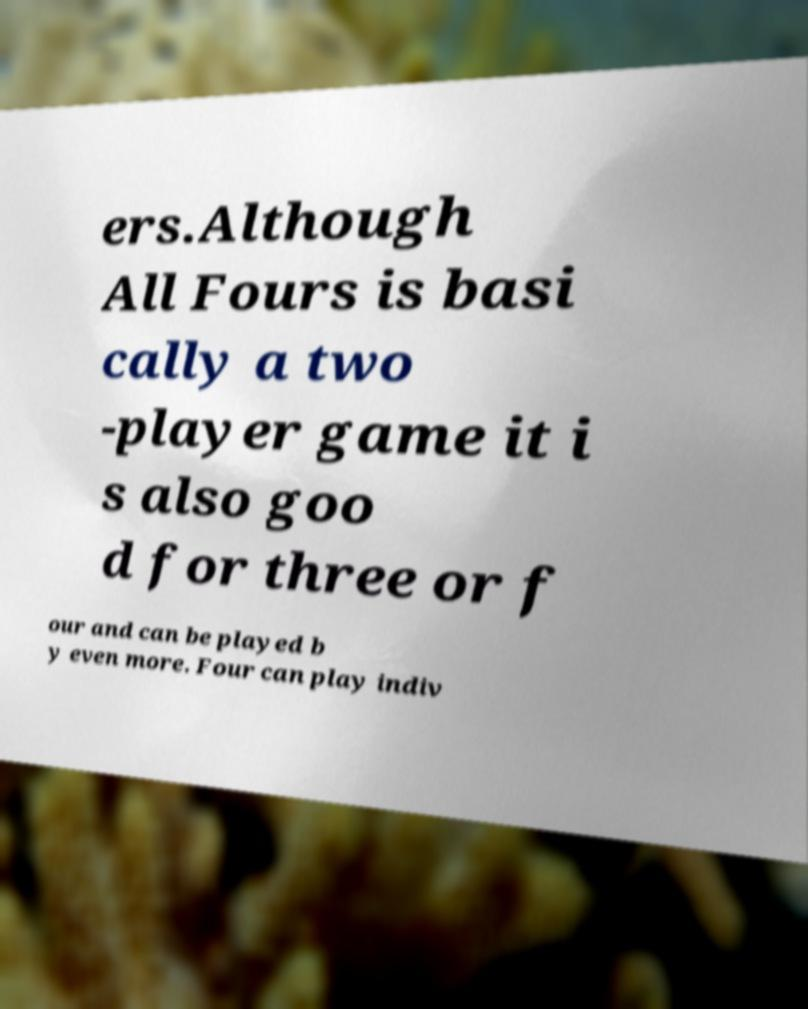Could you extract and type out the text from this image? ers.Although All Fours is basi cally a two -player game it i s also goo d for three or f our and can be played b y even more. Four can play indiv 